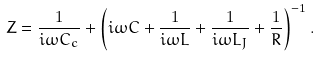<formula> <loc_0><loc_0><loc_500><loc_500>Z = \frac { 1 } { i \omega C _ { c } } + \left ( i \omega C + \frac { 1 } { i \omega L } + \frac { 1 } { i \omega L _ { J } } + \frac { 1 } { R } \right ) ^ { - 1 } .</formula> 